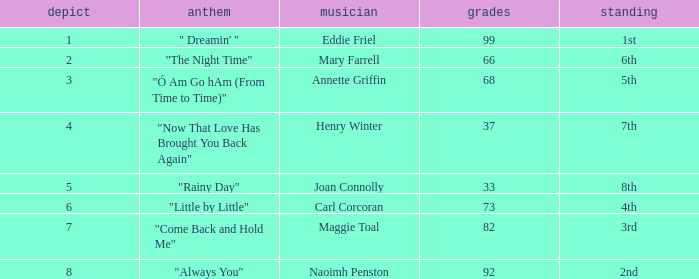What is the lowest points when the ranking is 1st? 99.0. 